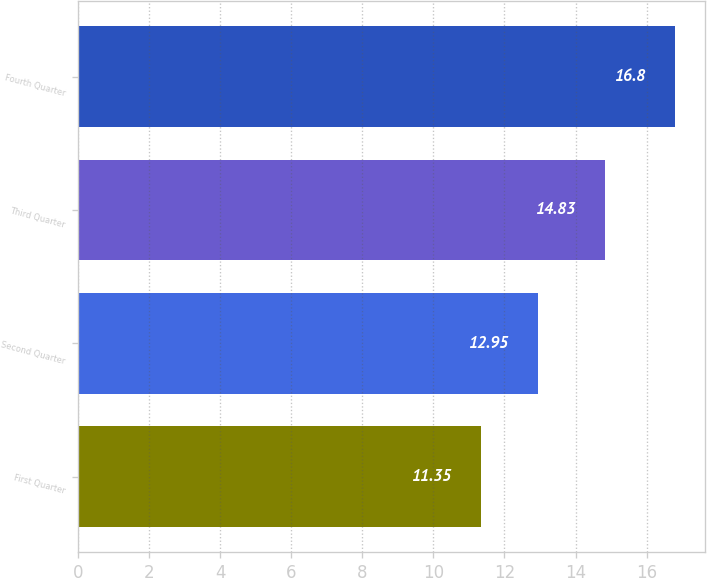<chart> <loc_0><loc_0><loc_500><loc_500><bar_chart><fcel>First Quarter<fcel>Second Quarter<fcel>Third Quarter<fcel>Fourth Quarter<nl><fcel>11.35<fcel>12.95<fcel>14.83<fcel>16.8<nl></chart> 